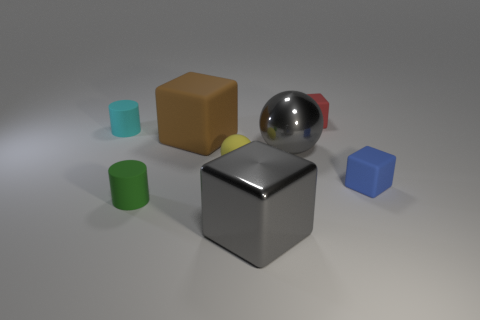Subtract all matte cubes. How many cubes are left? 1 Add 1 tiny cylinders. How many objects exist? 9 Subtract all green cubes. Subtract all brown cylinders. How many cubes are left? 4 Subtract all cylinders. How many objects are left? 6 Subtract all large gray cubes. Subtract all tiny red rubber cubes. How many objects are left? 6 Add 1 small red blocks. How many small red blocks are left? 2 Add 7 large balls. How many large balls exist? 8 Subtract 1 gray balls. How many objects are left? 7 